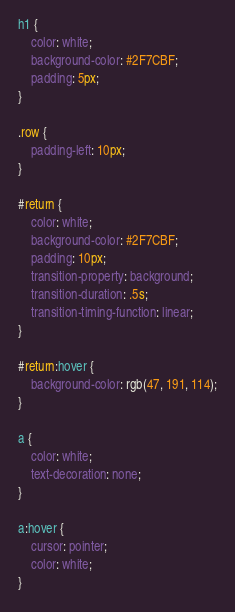<code> <loc_0><loc_0><loc_500><loc_500><_CSS_>h1 {
    color: white;
    background-color: #2F7CBF;
    padding: 5px;
}

.row {
    padding-left: 10px;
}

#return {
    color: white;
    background-color: #2F7CBF;
    padding: 10px;
    transition-property: background;
    transition-duration: .5s;
    transition-timing-function: linear;
}

#return:hover {
    background-color: rgb(47, 191, 114);
}

a {
    color: white;
    text-decoration: none;
}

a:hover {
    cursor: pointer;
    color: white;
}
</code> 